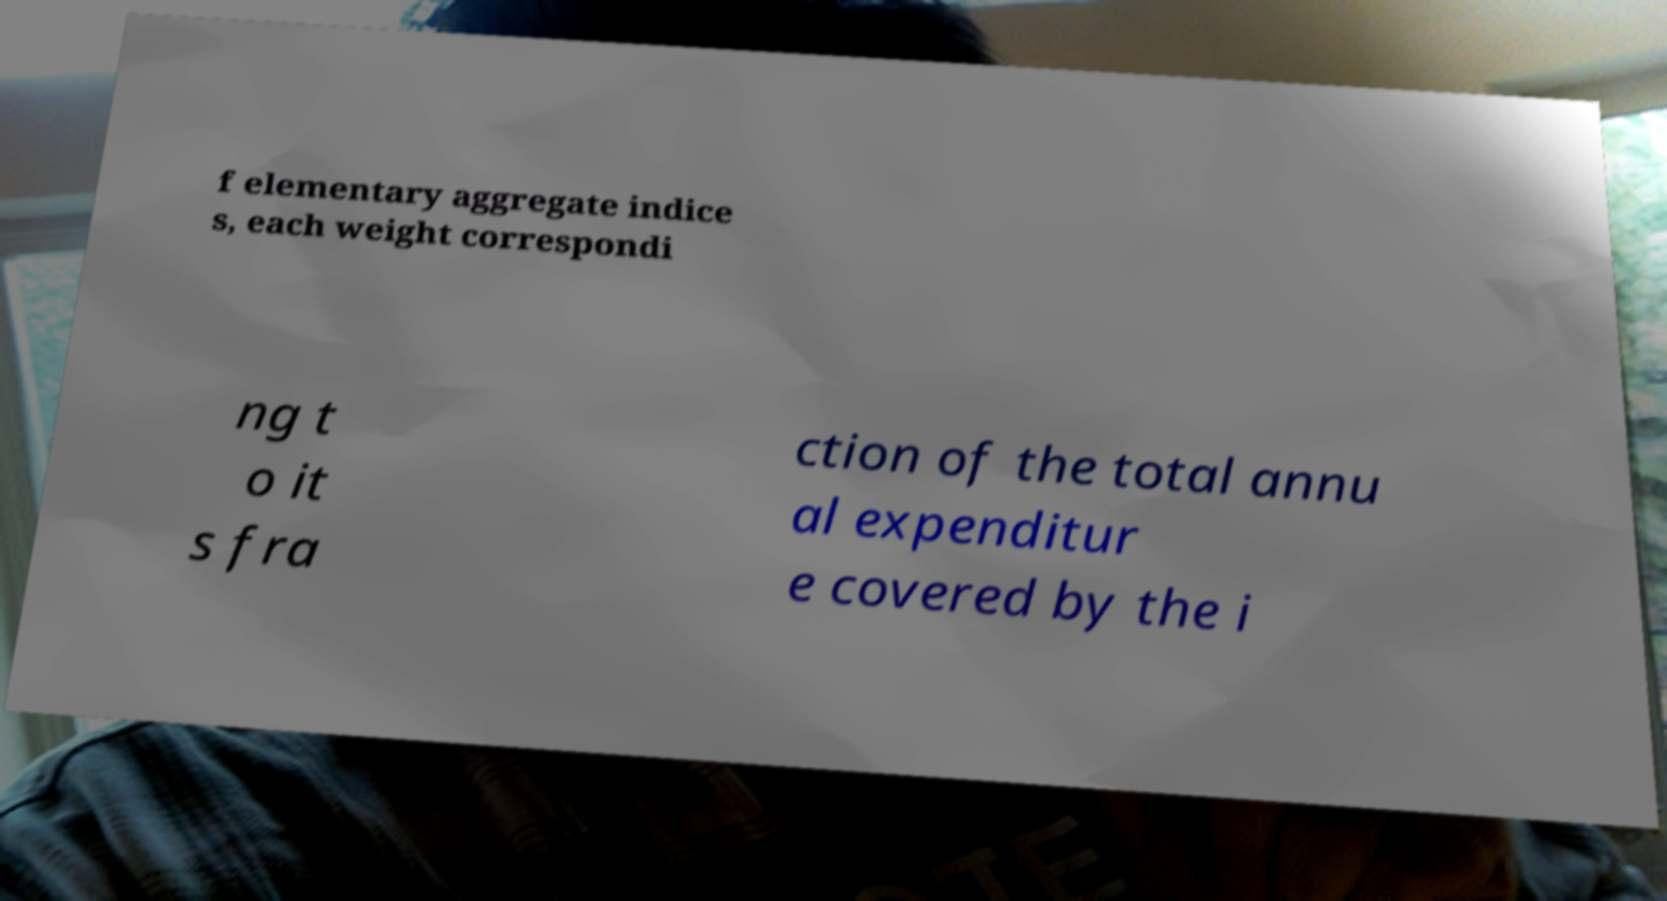There's text embedded in this image that I need extracted. Can you transcribe it verbatim? f elementary aggregate indice s, each weight correspondi ng t o it s fra ction of the total annu al expenditur e covered by the i 